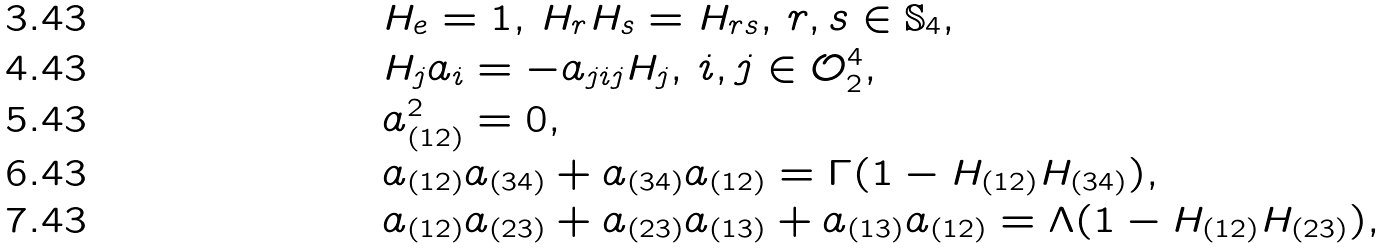Convert formula to latex. <formula><loc_0><loc_0><loc_500><loc_500>& H _ { e } = 1 , \, H _ { r } H _ { s } = H _ { r s } , \, r , s \in \mathbb { S } _ { 4 } , \\ & H _ { j } a _ { i } = - a _ { j i j } H _ { j } , \, i , j \in \mathcal { O } ^ { 4 } _ { 2 } , \\ & a ^ { 2 } _ { ( 1 2 ) } = 0 , \\ & a _ { ( 1 2 ) } a _ { ( 3 4 ) } + a _ { ( 3 4 ) } a _ { ( 1 2 ) } = \Gamma ( 1 - H _ { ( 1 2 ) } H _ { ( 3 4 ) } ) , \\ & a _ { ( 1 2 ) } a _ { ( 2 3 ) } + a _ { ( 2 3 ) } a _ { ( 1 3 ) } + a _ { ( 1 3 ) } a _ { ( 1 2 ) } = \Lambda ( 1 - H _ { ( 1 2 ) } H _ { ( 2 3 ) } ) ,</formula> 